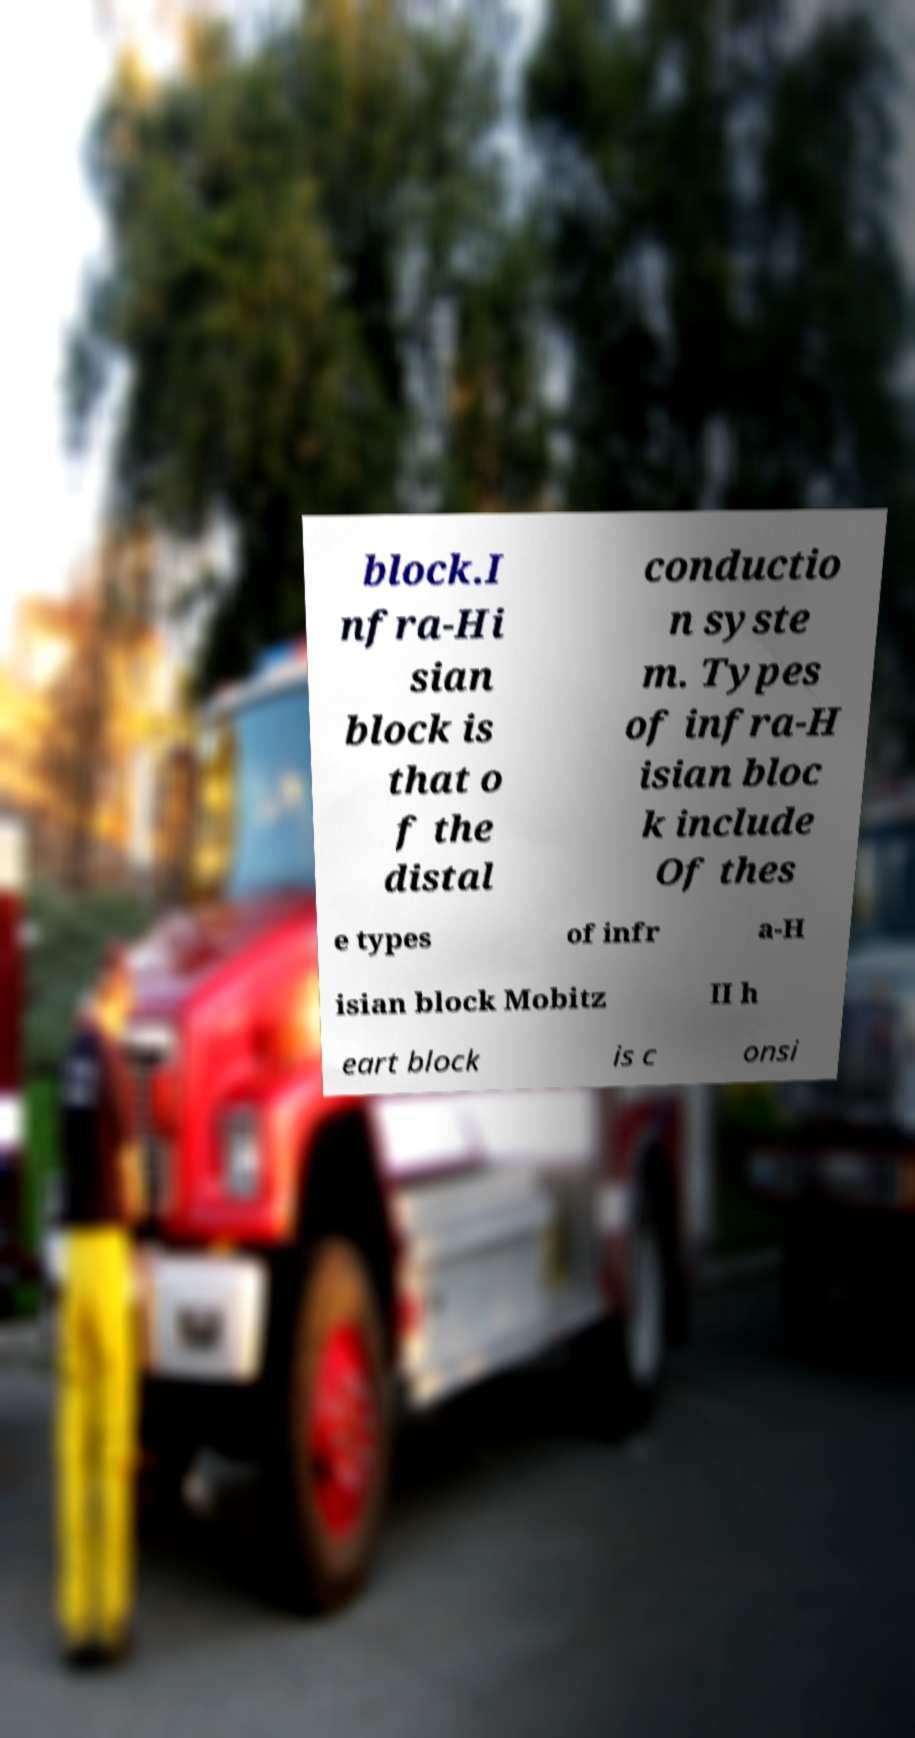What messages or text are displayed in this image? I need them in a readable, typed format. block.I nfra-Hi sian block is that o f the distal conductio n syste m. Types of infra-H isian bloc k include Of thes e types of infr a-H isian block Mobitz II h eart block is c onsi 